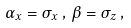Convert formula to latex. <formula><loc_0><loc_0><loc_500><loc_500>\alpha _ { x } = \sigma _ { x } \, , \, \beta = \sigma _ { z } \, ,</formula> 